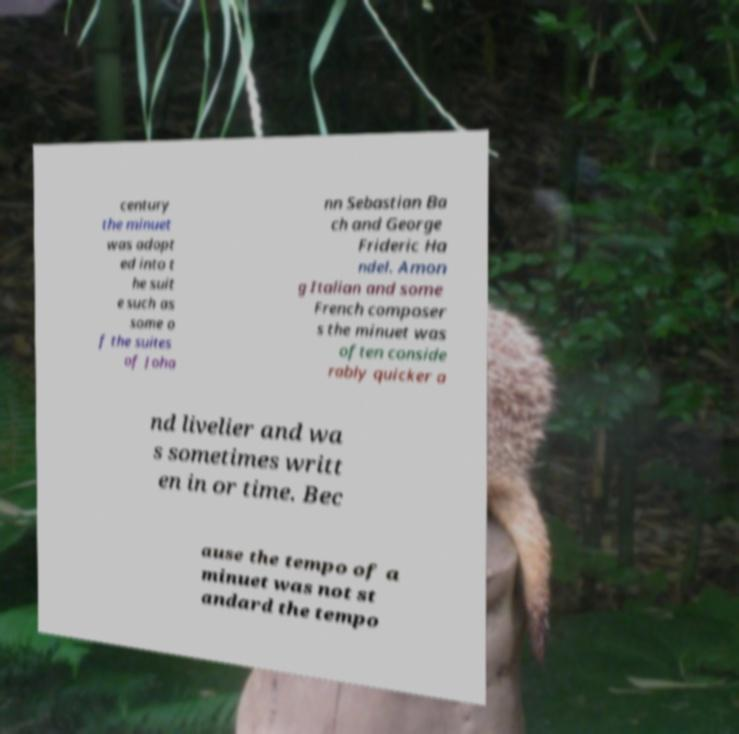Can you read and provide the text displayed in the image?This photo seems to have some interesting text. Can you extract and type it out for me? century the minuet was adopt ed into t he suit e such as some o f the suites of Joha nn Sebastian Ba ch and George Frideric Ha ndel. Amon g Italian and some French composer s the minuet was often conside rably quicker a nd livelier and wa s sometimes writt en in or time. Bec ause the tempo of a minuet was not st andard the tempo 